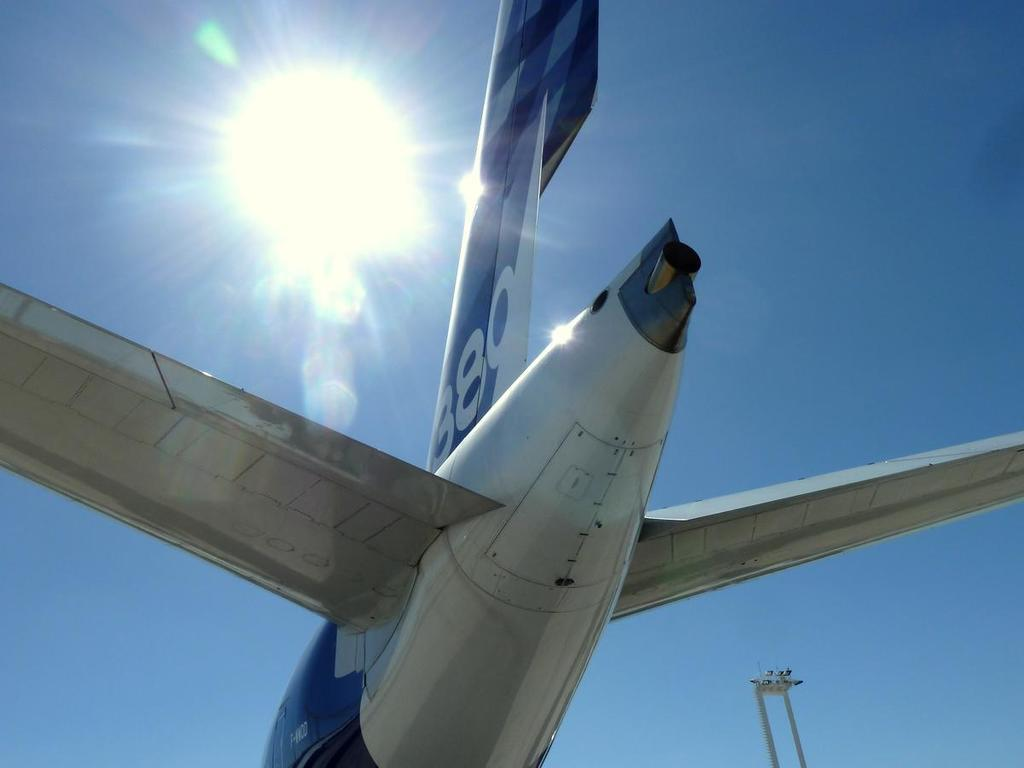<image>
Provide a brief description of the given image. the tail of a blue and white airplane number 389 